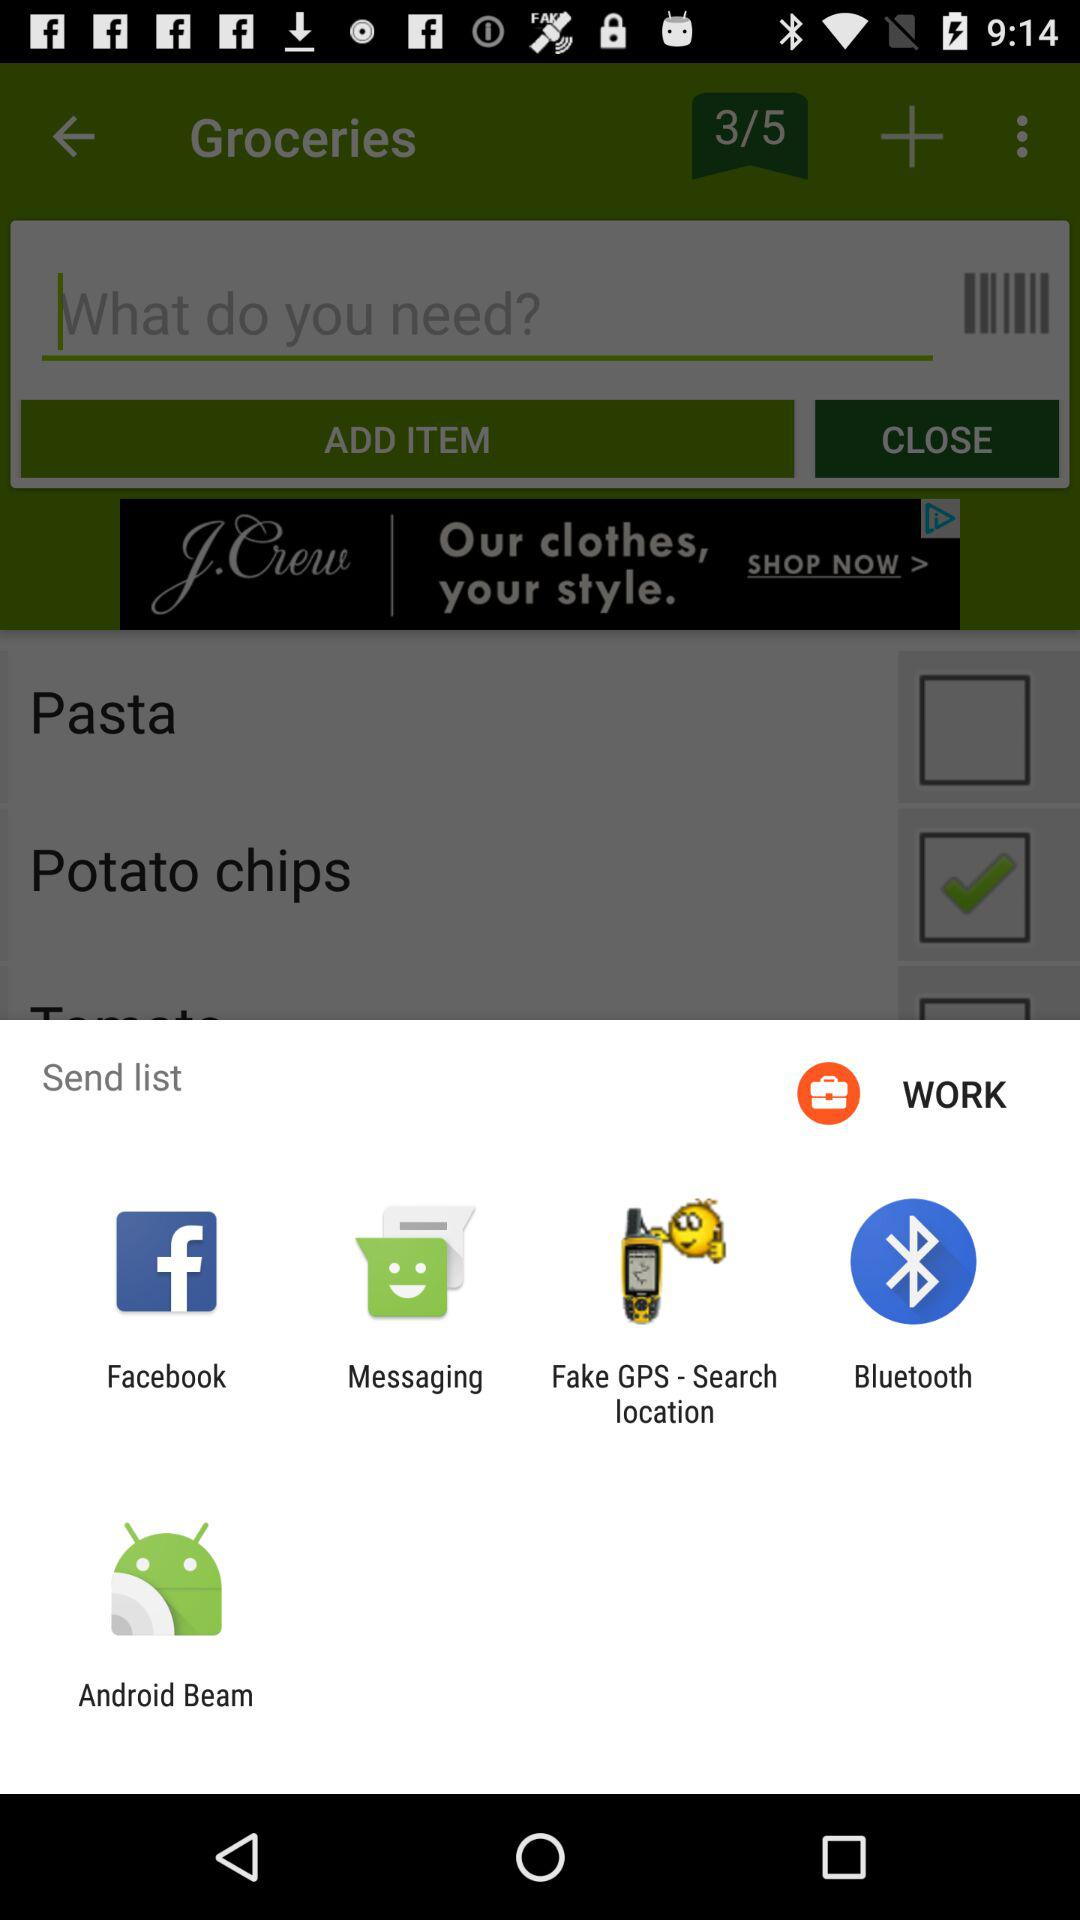By which apps can we send the list? You can send the list by "Facebook", "Messaging", "Fake GPS - Search location", "Bluetooth" and "Android Beam". 